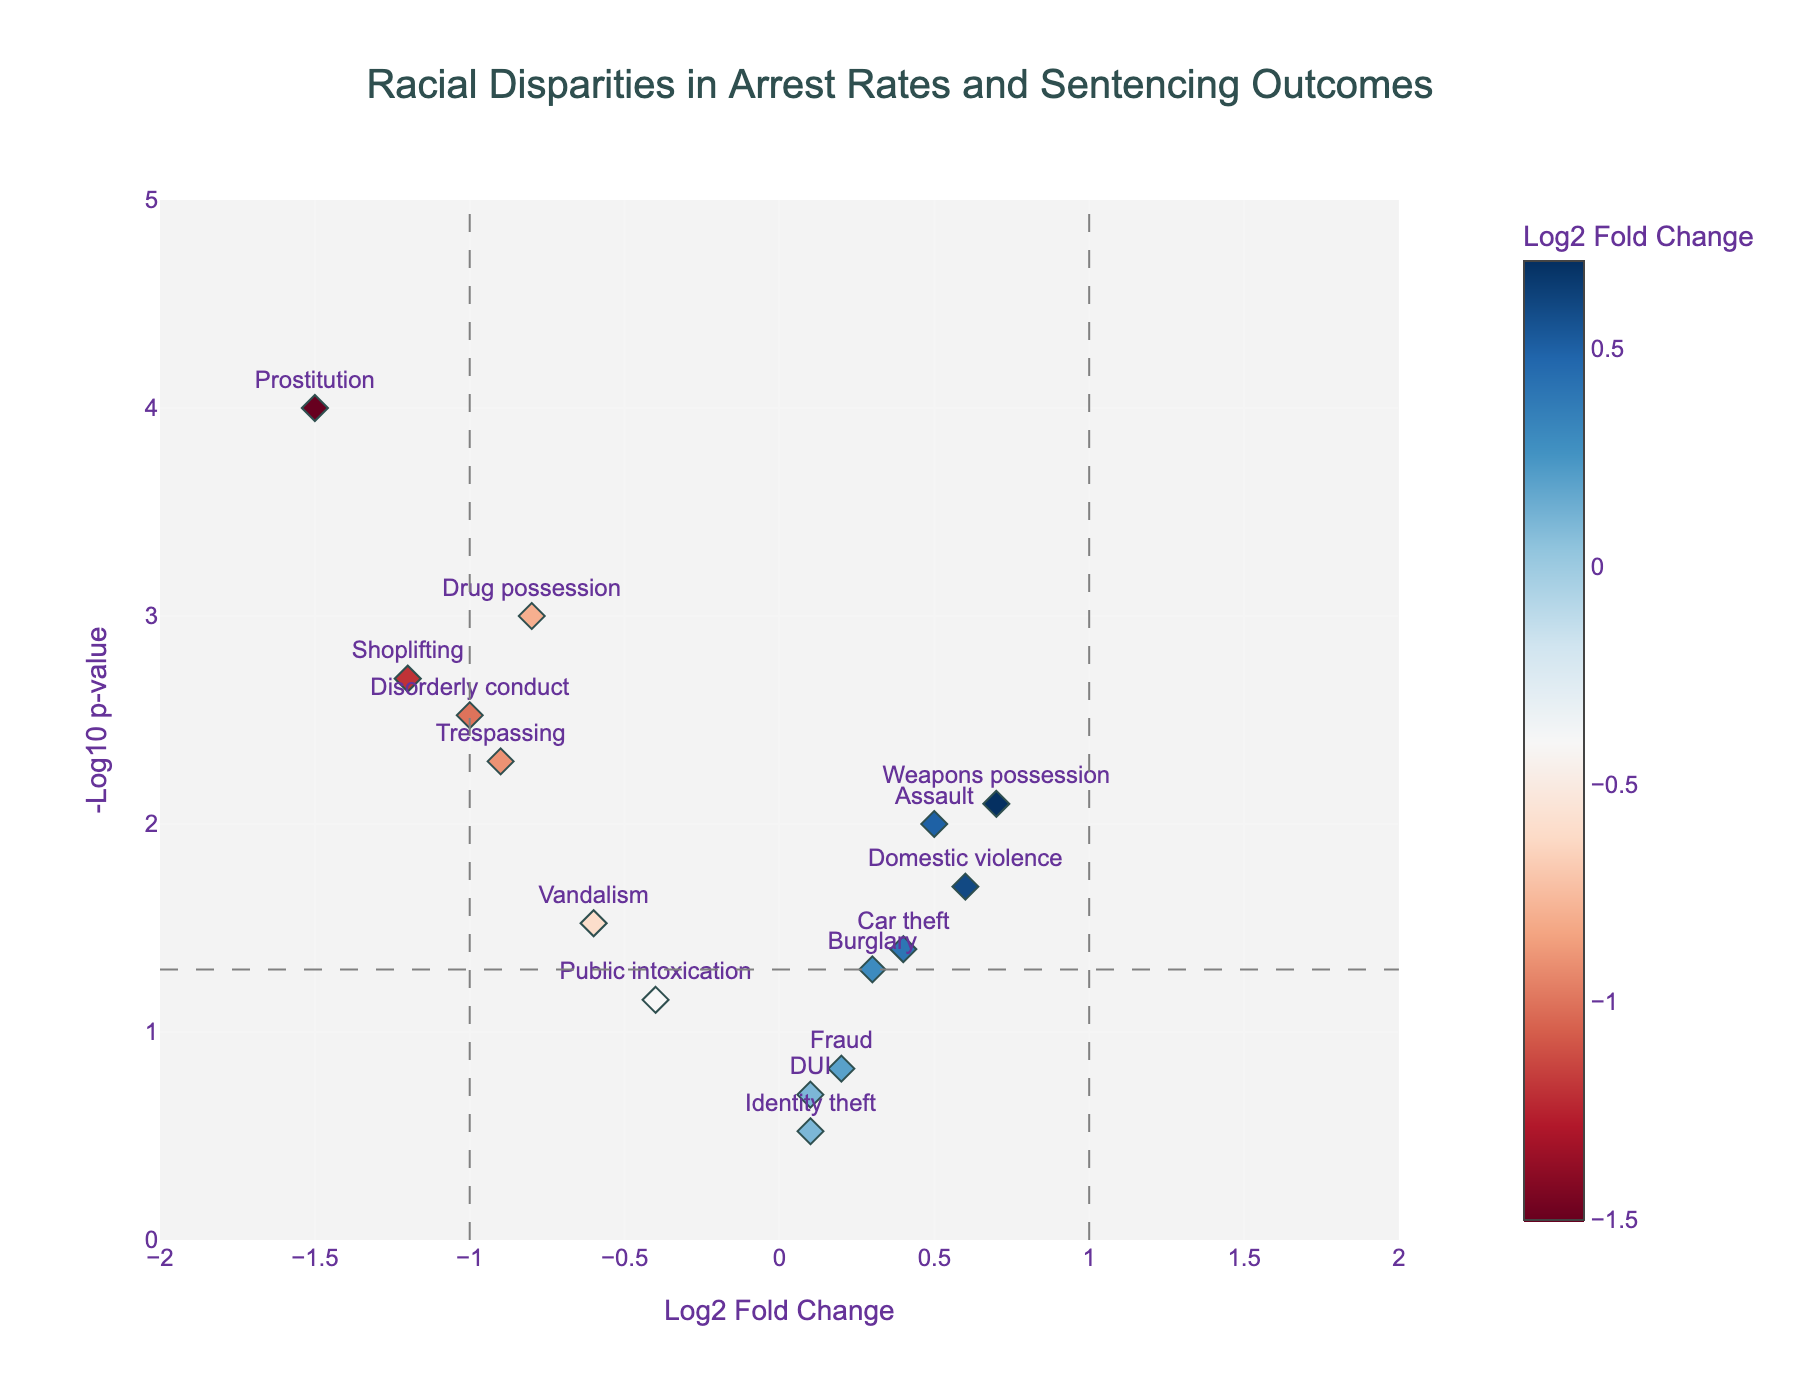What is the title of the plot? The title of the plot is positioned at the top center and reads "Racial Disparities in Arrest Rates and Sentencing Outcomes."
Answer: Racial Disparities in Arrest Rates and Sentencing Outcomes How many offense categories have a statistically significant p-value below 0.05? Any points above the horizontal dashed line at y=-log10(0.05) represent statistically significant p-values. Counting these points, there are 11 categories.
Answer: 11 Which offense category has the highest log2 fold change? The marker with the highest positive x-value corresponds to "Weapons possession" at a log2 fold change of 0.7.
Answer: Weapons possession Which offense has the lowest p-value and what is the log2 fold change for it? The lowest p-value corresponds to the highest y-value on the plot. "Prostitution" has the highest y-value, indicating the lowest p-value, and its log2 fold change is -1.5.
Answer: Prostitution, -1.5 Which offense categories have a log2 fold change below -1? Offense categories with a log2 fold change below -1 are to the left of the vertical dashed line at x=-1. They include "Shoplifting" and "Prostitution."
Answer: Shoplifting, Prostitution What is the log2 fold change and p-value for "Assault"? "Assault" is located at the point with label "Assault". From the hover information, it has a log2 fold change of 0.5 and a p-value of 0.01.
Answer: 0.5, 0.01 Among all offense categories, which categories are least affected based on log2 fold change? Explain. Categories close to the x=0 line are least affected. "DUI" and "Identity theft" have log2 fold changes of 0.1 and 0.1, respectively.
Answer: DUI, Identity theft Compare the p-values of "Drug possession" and "Car theft." Which has a lower p-value? By looking at the y-values of "Drug possession" and "Car theft," "Drug possession" has a higher y-value, meaning it has a lower p-value.
Answer: Drug possession Identify any offense categories where the log2 fold change is positive and statistically significant. Positive log2 fold changes are to the right of the y-axis. Points above the horizontal dashed line indicate statistical significance. "Assault," "Weapons possession," and "Domestic violence" meet these criteria.
Answer: Assault, Weapons possession, Domestic violence What is the range of the y-axis, and what does it represent? The y-axis ranges from 0 to 5 and represents the -log10 of the p-value, with higher values indicating lower p-values (more statistically significant results).
Answer: 0 to 5 